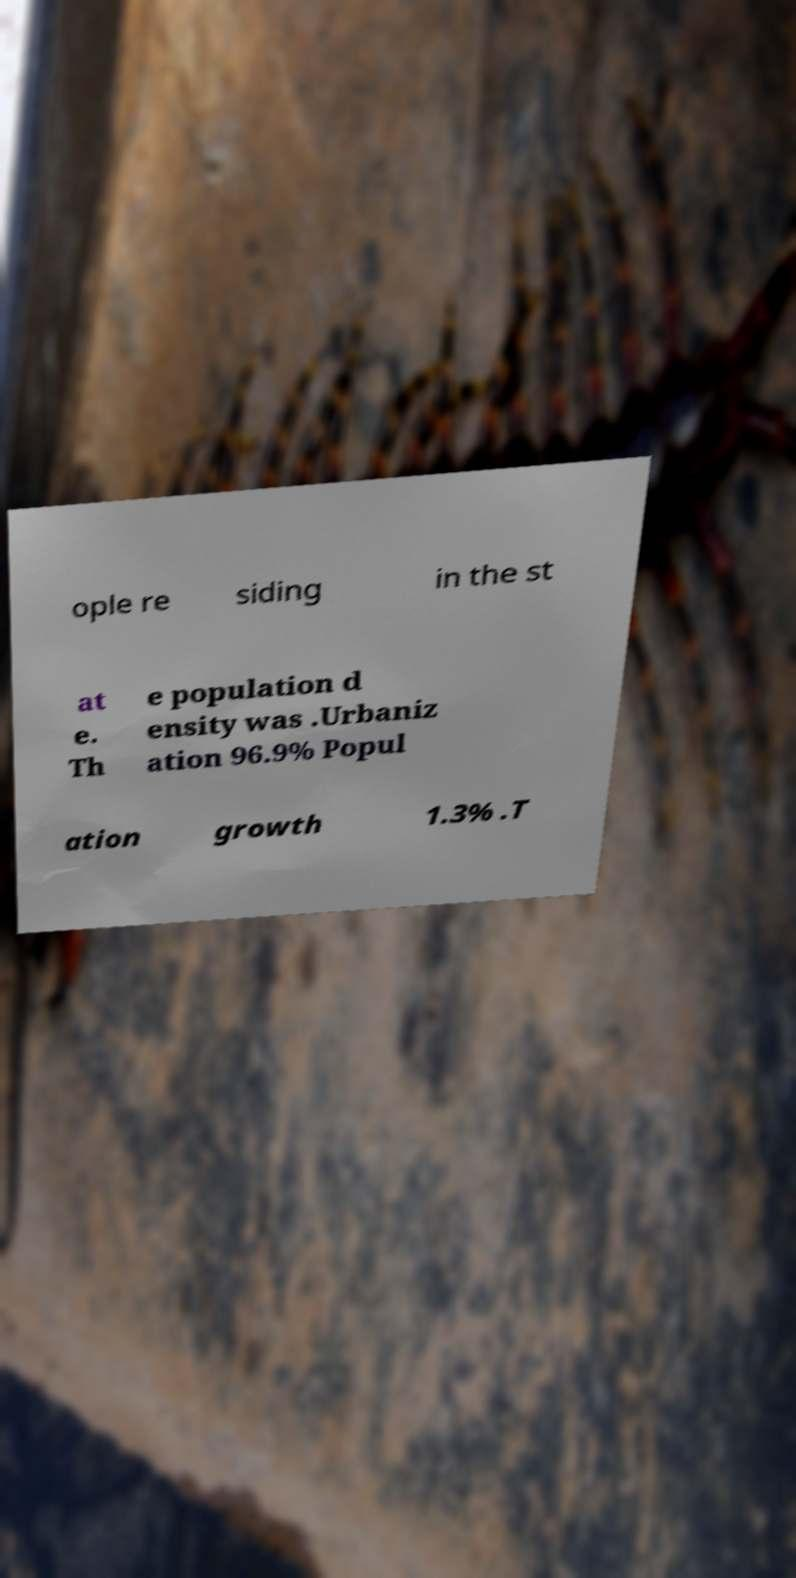For documentation purposes, I need the text within this image transcribed. Could you provide that? ople re siding in the st at e. Th e population d ensity was .Urbaniz ation 96.9% Popul ation growth 1.3% .T 